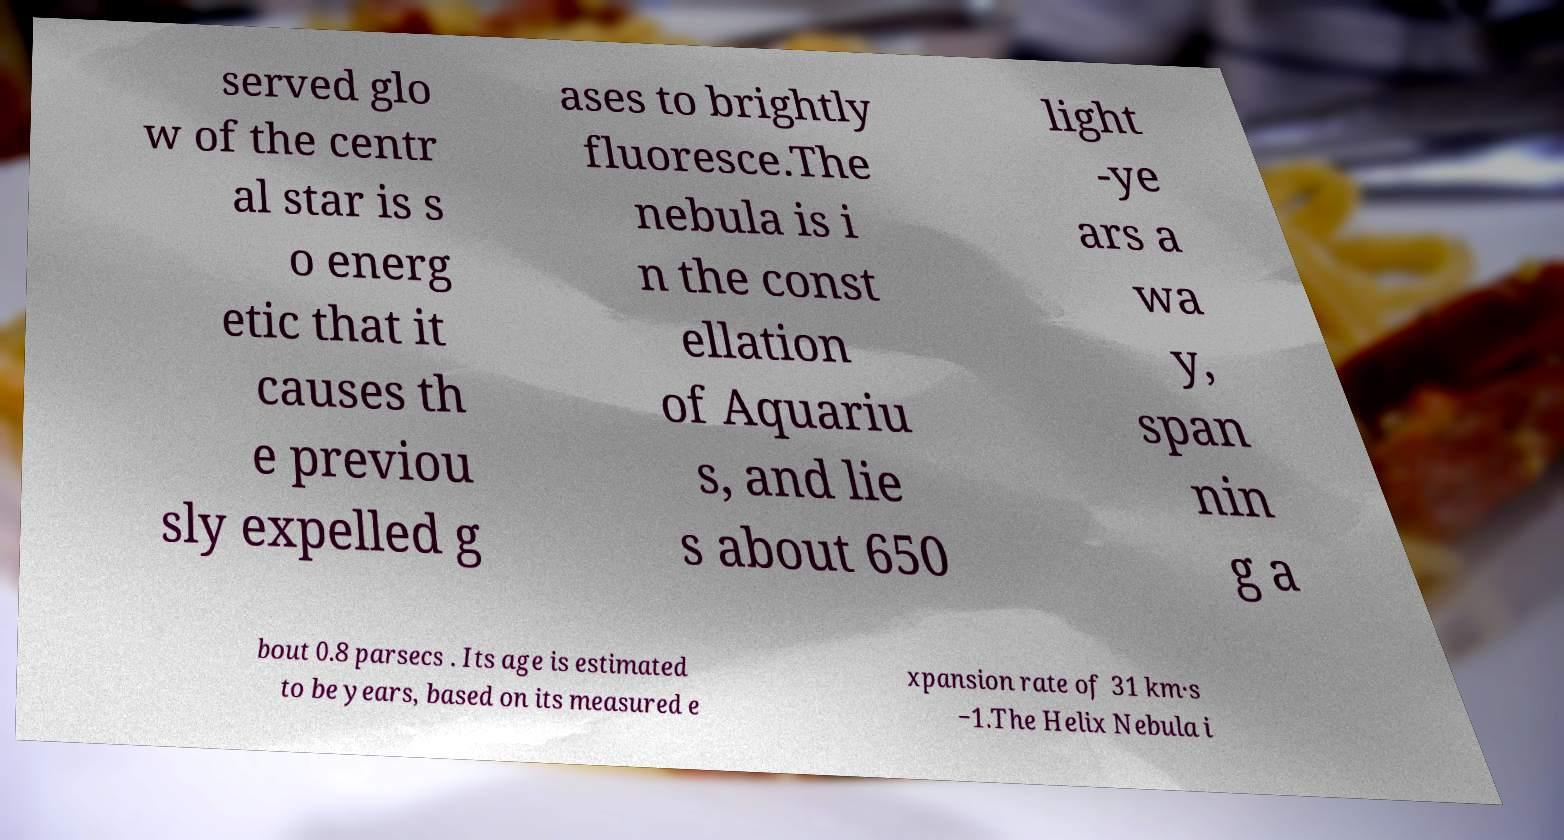Can you accurately transcribe the text from the provided image for me? served glo w of the centr al star is s o energ etic that it causes th e previou sly expelled g ases to brightly fluoresce.The nebula is i n the const ellation of Aquariu s, and lie s about 650 light -ye ars a wa y, span nin g a bout 0.8 parsecs . Its age is estimated to be years, based on its measured e xpansion rate of 31 km·s −1.The Helix Nebula i 